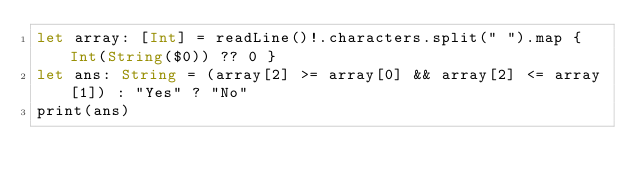<code> <loc_0><loc_0><loc_500><loc_500><_Swift_>let array: [Int] = readLine()!.characters.split(" ").map { Int(String($0)) ?? 0 }
let ans: String = (array[2] >= array[0] && array[2] <= array[1]) : "Yes" ? "No"
print(ans)
</code> 